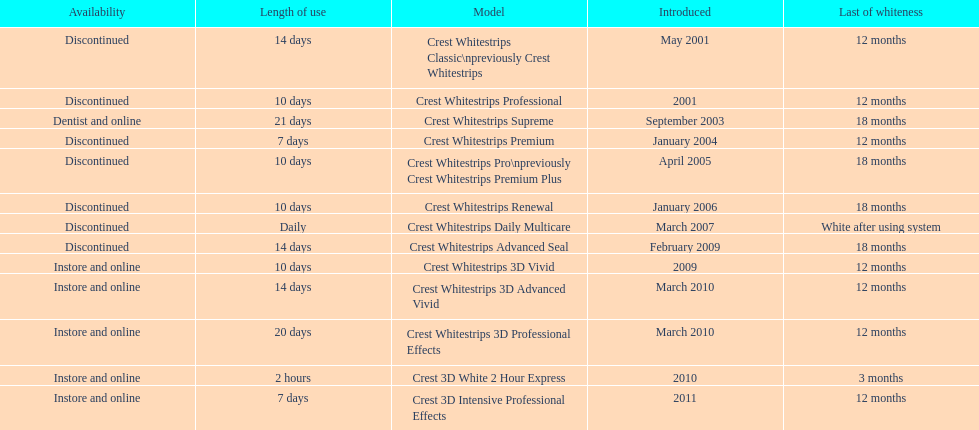How many models require less than a week of use? 2. 